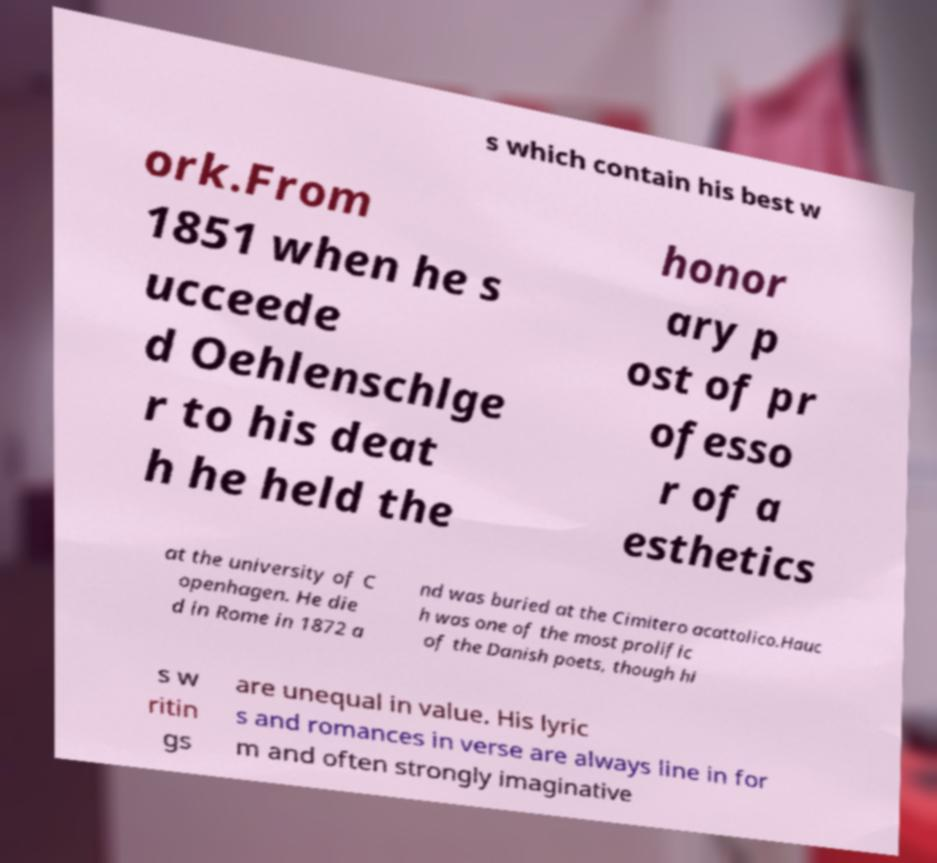Can you accurately transcribe the text from the provided image for me? s which contain his best w ork.From 1851 when he s ucceede d Oehlenschlge r to his deat h he held the honor ary p ost of pr ofesso r of a esthetics at the university of C openhagen. He die d in Rome in 1872 a nd was buried at the Cimitero acattolico.Hauc h was one of the most prolific of the Danish poets, though hi s w ritin gs are unequal in value. His lyric s and romances in verse are always line in for m and often strongly imaginative 